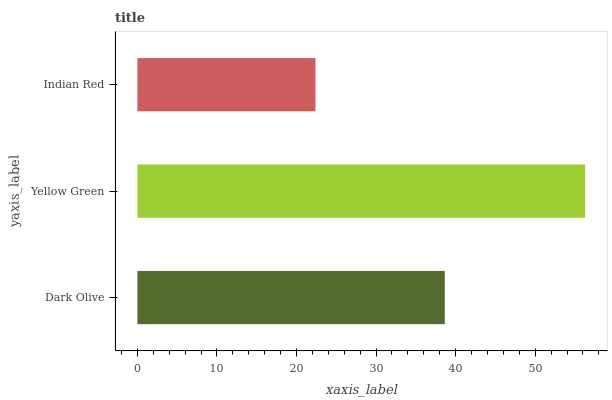Is Indian Red the minimum?
Answer yes or no. Yes. Is Yellow Green the maximum?
Answer yes or no. Yes. Is Yellow Green the minimum?
Answer yes or no. No. Is Indian Red the maximum?
Answer yes or no. No. Is Yellow Green greater than Indian Red?
Answer yes or no. Yes. Is Indian Red less than Yellow Green?
Answer yes or no. Yes. Is Indian Red greater than Yellow Green?
Answer yes or no. No. Is Yellow Green less than Indian Red?
Answer yes or no. No. Is Dark Olive the high median?
Answer yes or no. Yes. Is Dark Olive the low median?
Answer yes or no. Yes. Is Yellow Green the high median?
Answer yes or no. No. Is Indian Red the low median?
Answer yes or no. No. 